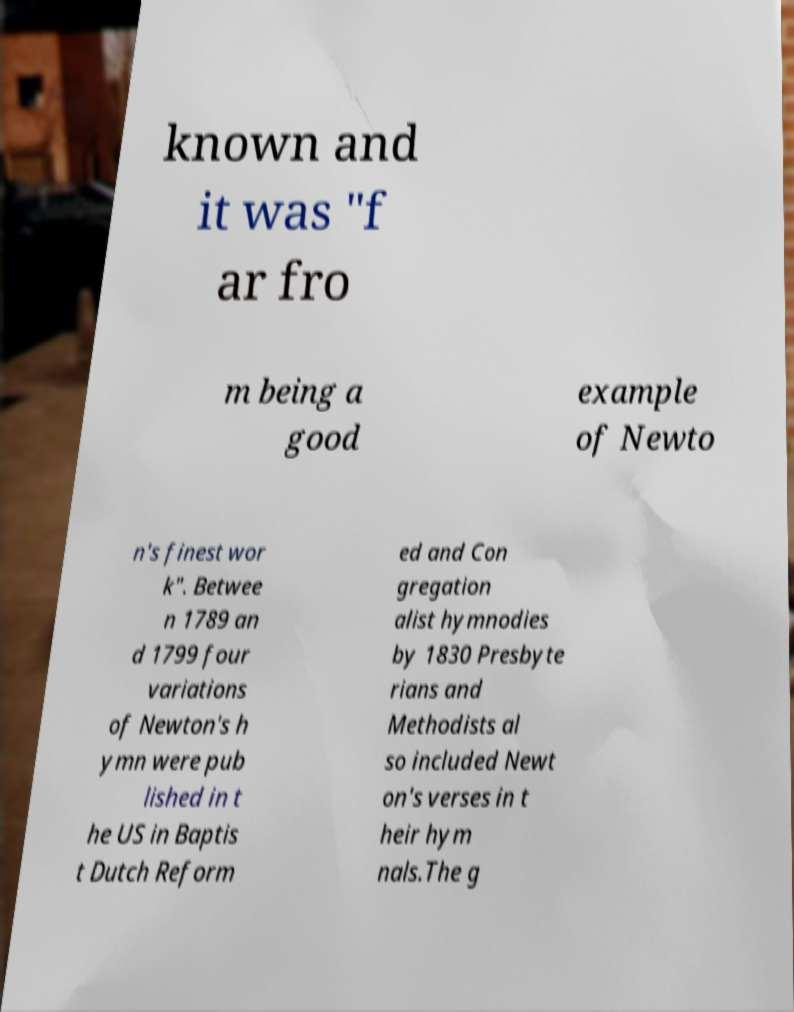Can you read and provide the text displayed in the image?This photo seems to have some interesting text. Can you extract and type it out for me? known and it was "f ar fro m being a good example of Newto n's finest wor k". Betwee n 1789 an d 1799 four variations of Newton's h ymn were pub lished in t he US in Baptis t Dutch Reform ed and Con gregation alist hymnodies by 1830 Presbyte rians and Methodists al so included Newt on's verses in t heir hym nals.The g 